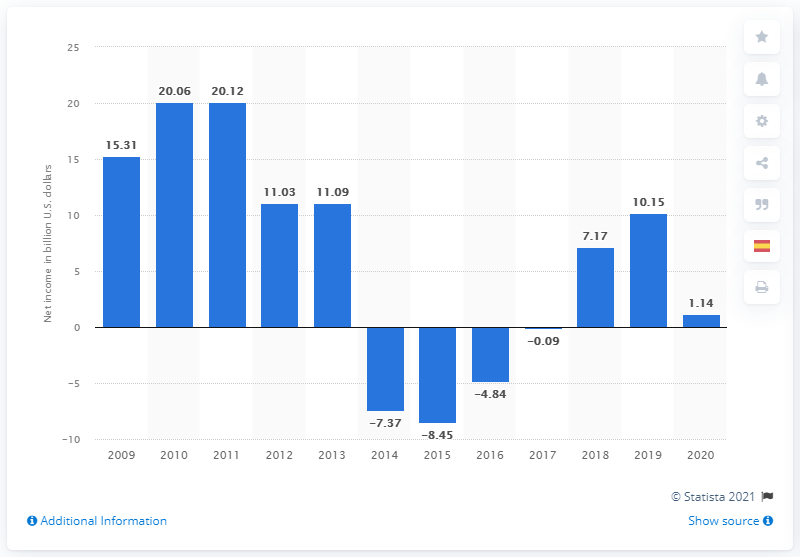Specify some key components in this picture. Petrobras reported a net income of 1.14 billion US dollars in 2020. 